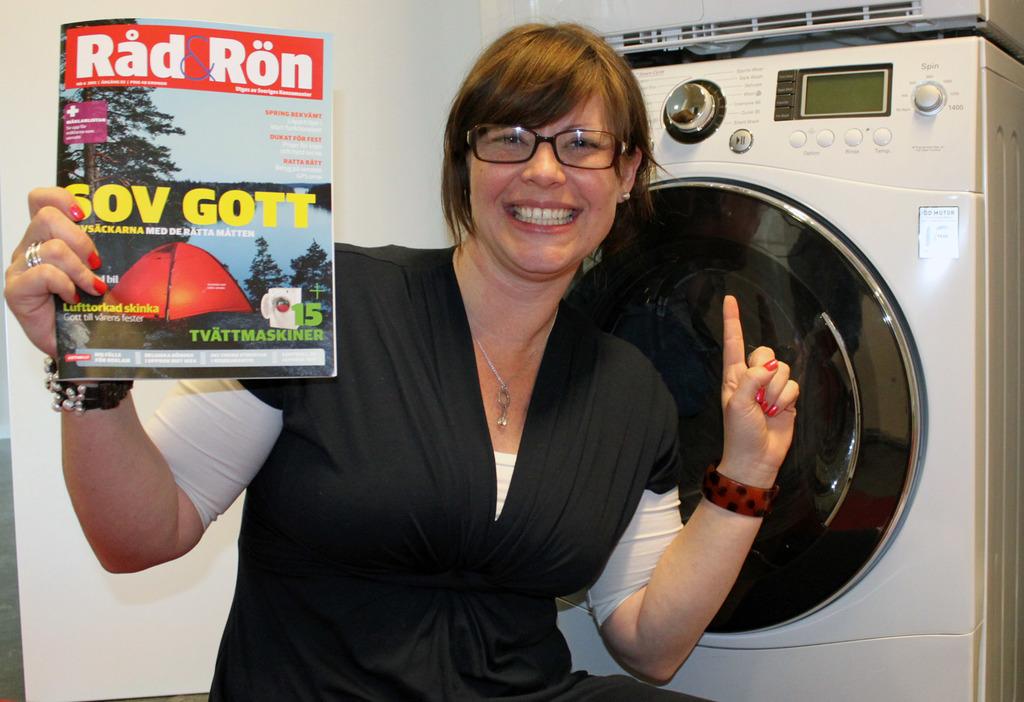What is the name of the magazine?
Keep it short and to the point. Rad & ron. What  number is in green on the magazine?
Ensure brevity in your answer.  15. 